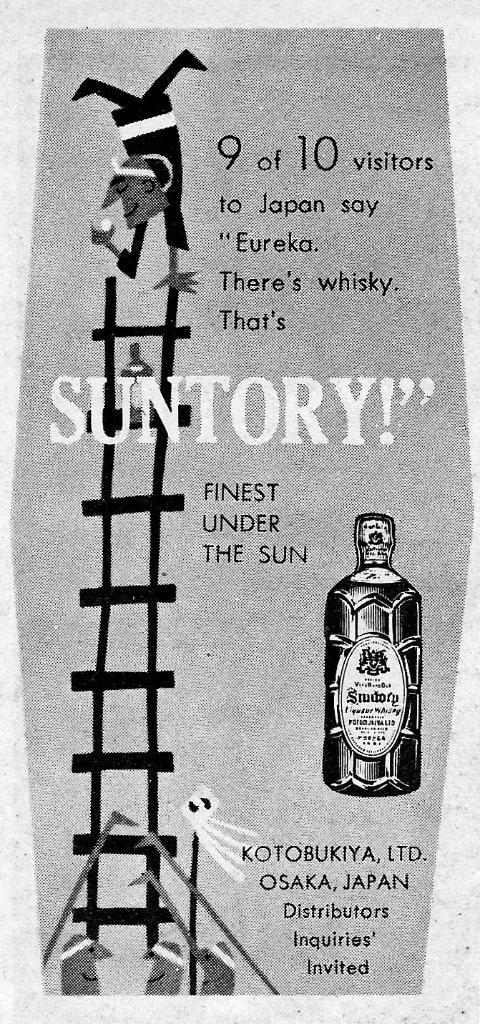Provide a one-sentence caption for the provided image. 9 out of 10 visitors to Japan say "Eureka. There's whisky. That's SUNTORY!". 